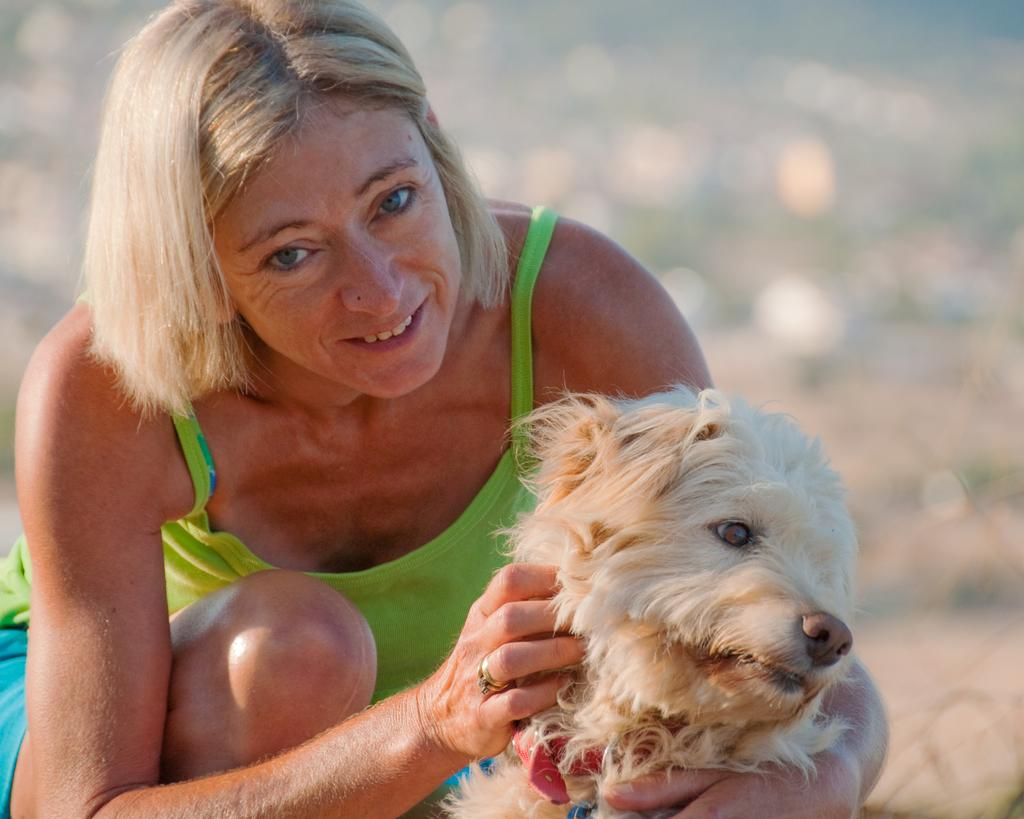Who is present in the image? There is a woman in the image. What is the woman holding? The woman is holding a dog. What is the woman wearing? The woman is wearing a green dress. What can be seen in the background of the image? There is an open land in the background of the image. What type of cracker is the woman feeding to the dog in the image? There is no cracker present in the image, and the woman is not feeding anything to the dog. 